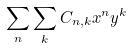Convert formula to latex. <formula><loc_0><loc_0><loc_500><loc_500>\sum _ { n } \sum _ { k } C _ { n , k } x ^ { n } y ^ { k }</formula> 